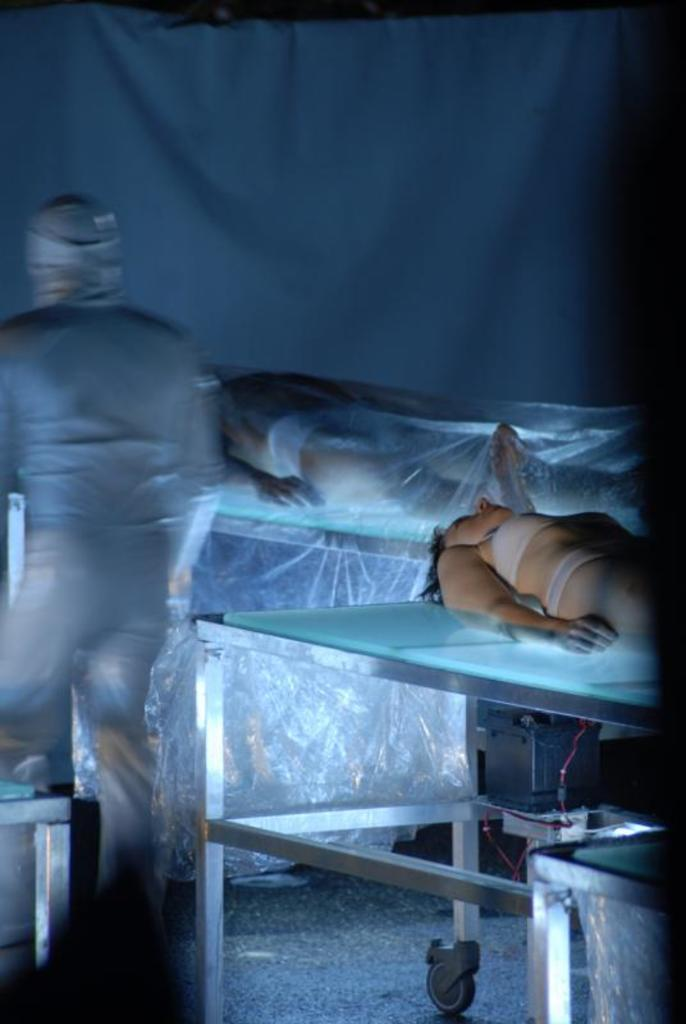What type of living organisms are in the image? There are humans in the image. What are the humans doing in the image? The humans are sleeping. What are the humans sleeping on in the image? The humans are sleeping on glass tables. Where are the glass tables located in the image? The glass tables are on the right side of the image. What type of nail can be seen being hammered into the arch in the image? There is no nail or arch present in the image; it features humans sleeping on glass tables. What type of quarter is visible on the glass table in the image? There is no quarter present on the glass table in the image. 